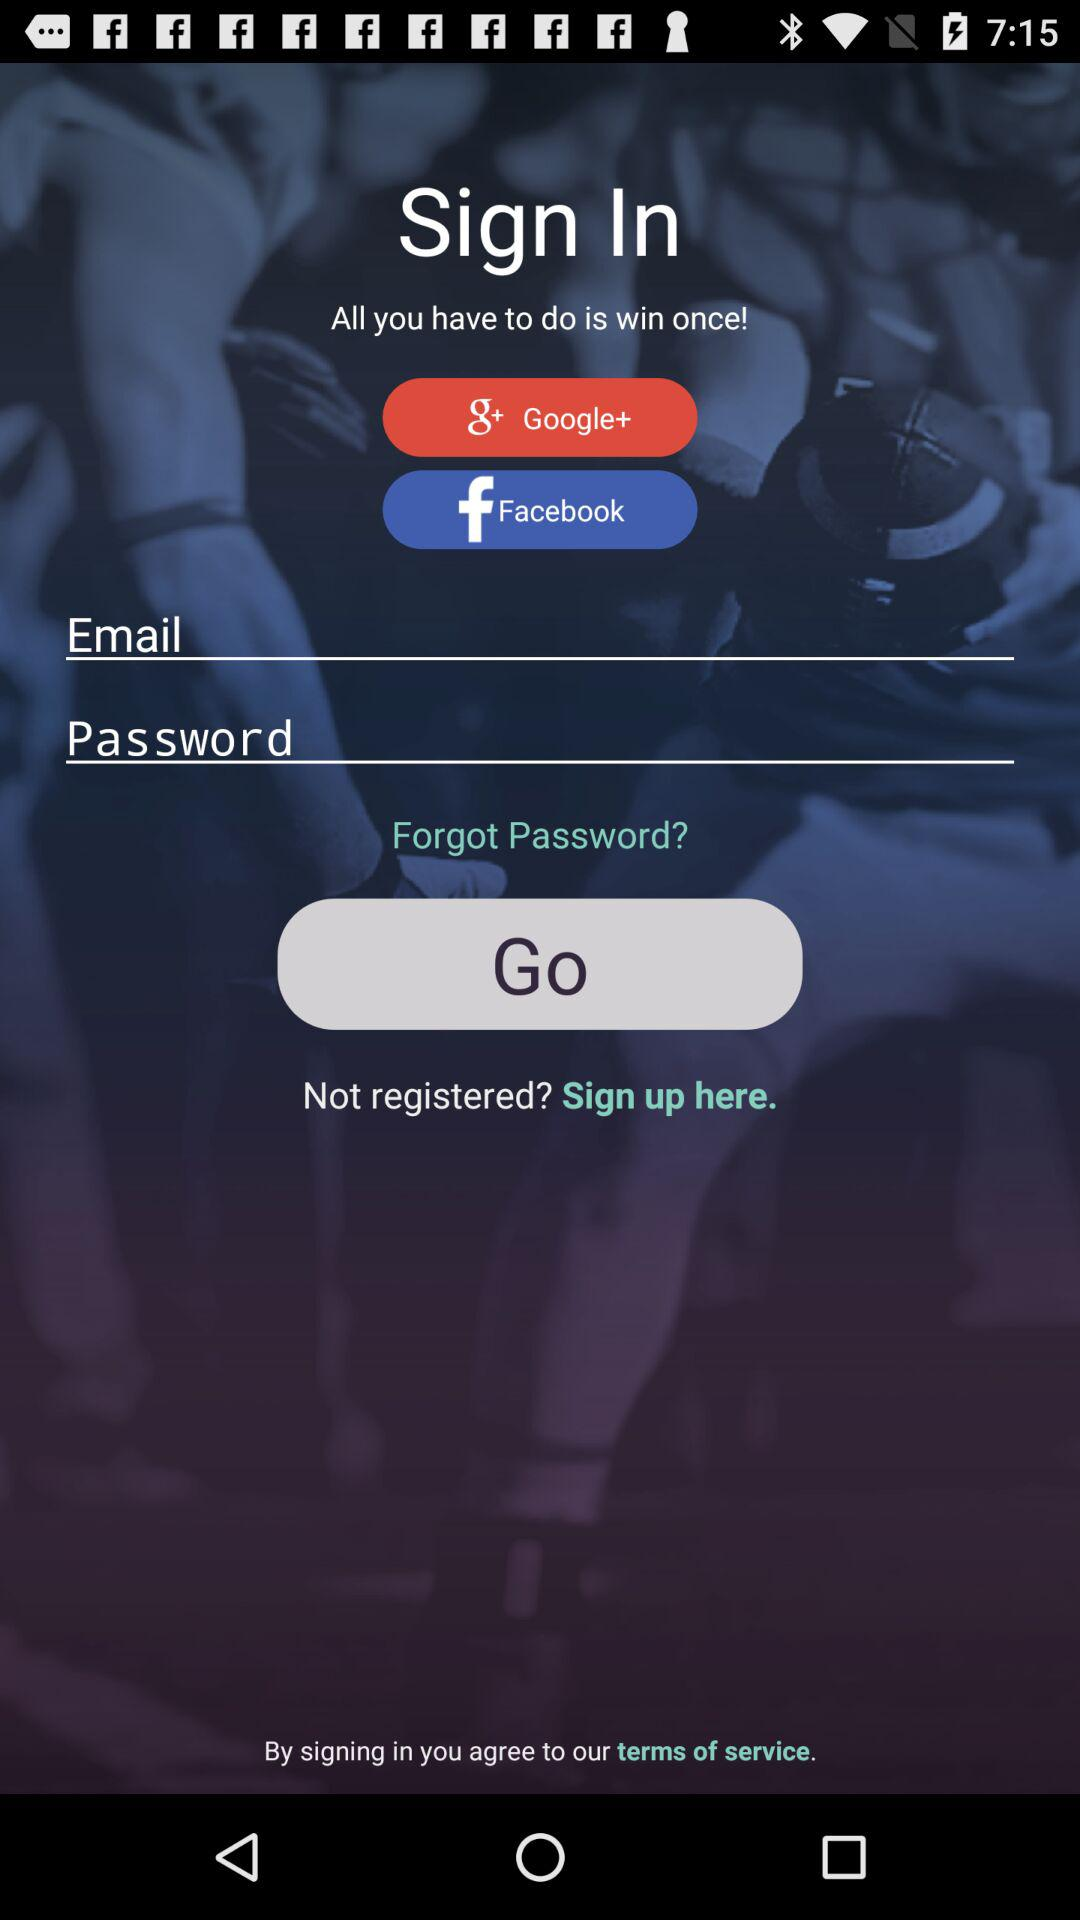What are the different options available for signing in? The different options available for signing in are "Google+", "Facebook" and "Email". 